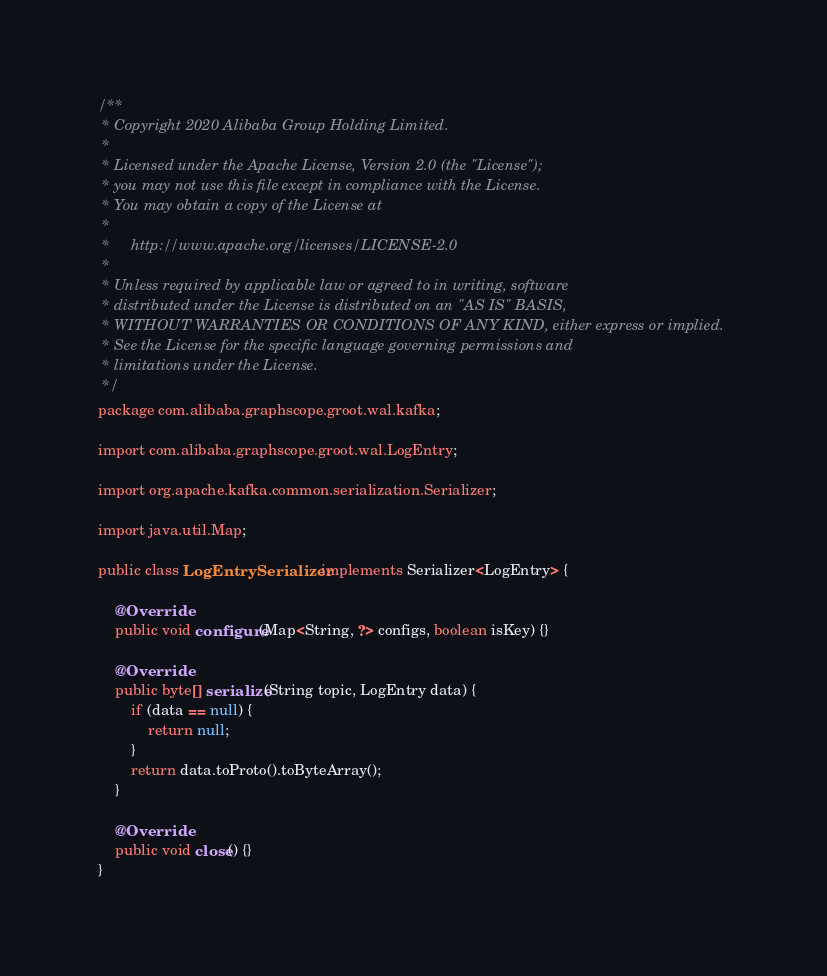Convert code to text. <code><loc_0><loc_0><loc_500><loc_500><_Java_>/**
 * Copyright 2020 Alibaba Group Holding Limited.
 *
 * Licensed under the Apache License, Version 2.0 (the "License");
 * you may not use this file except in compliance with the License.
 * You may obtain a copy of the License at
 *
 *     http://www.apache.org/licenses/LICENSE-2.0
 *
 * Unless required by applicable law or agreed to in writing, software
 * distributed under the License is distributed on an "AS IS" BASIS,
 * WITHOUT WARRANTIES OR CONDITIONS OF ANY KIND, either express or implied.
 * See the License for the specific language governing permissions and
 * limitations under the License.
 */
package com.alibaba.graphscope.groot.wal.kafka;

import com.alibaba.graphscope.groot.wal.LogEntry;

import org.apache.kafka.common.serialization.Serializer;

import java.util.Map;

public class LogEntrySerializer implements Serializer<LogEntry> {

    @Override
    public void configure(Map<String, ?> configs, boolean isKey) {}

    @Override
    public byte[] serialize(String topic, LogEntry data) {
        if (data == null) {
            return null;
        }
        return data.toProto().toByteArray();
    }

    @Override
    public void close() {}
}
</code> 